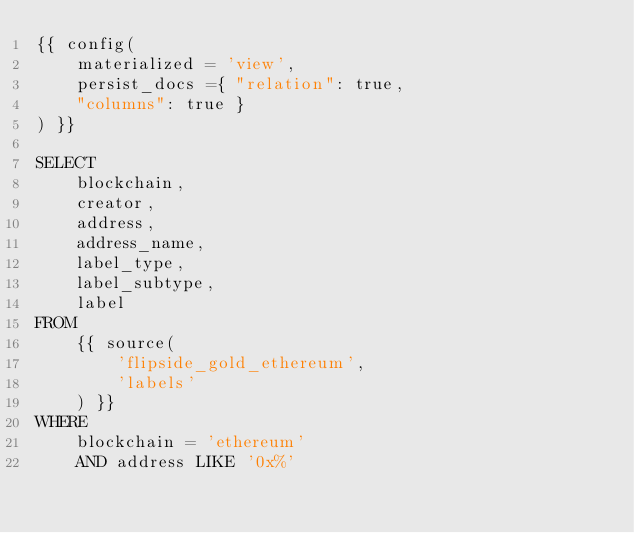Convert code to text. <code><loc_0><loc_0><loc_500><loc_500><_SQL_>{{ config(
    materialized = 'view',
    persist_docs ={ "relation": true,
    "columns": true }
) }}

SELECT
    blockchain,
    creator,
    address,
    address_name,
    label_type,
    label_subtype,
    label
FROM
    {{ source(
        'flipside_gold_ethereum',
        'labels'
    ) }}
WHERE
    blockchain = 'ethereum'
    AND address LIKE '0x%'
</code> 